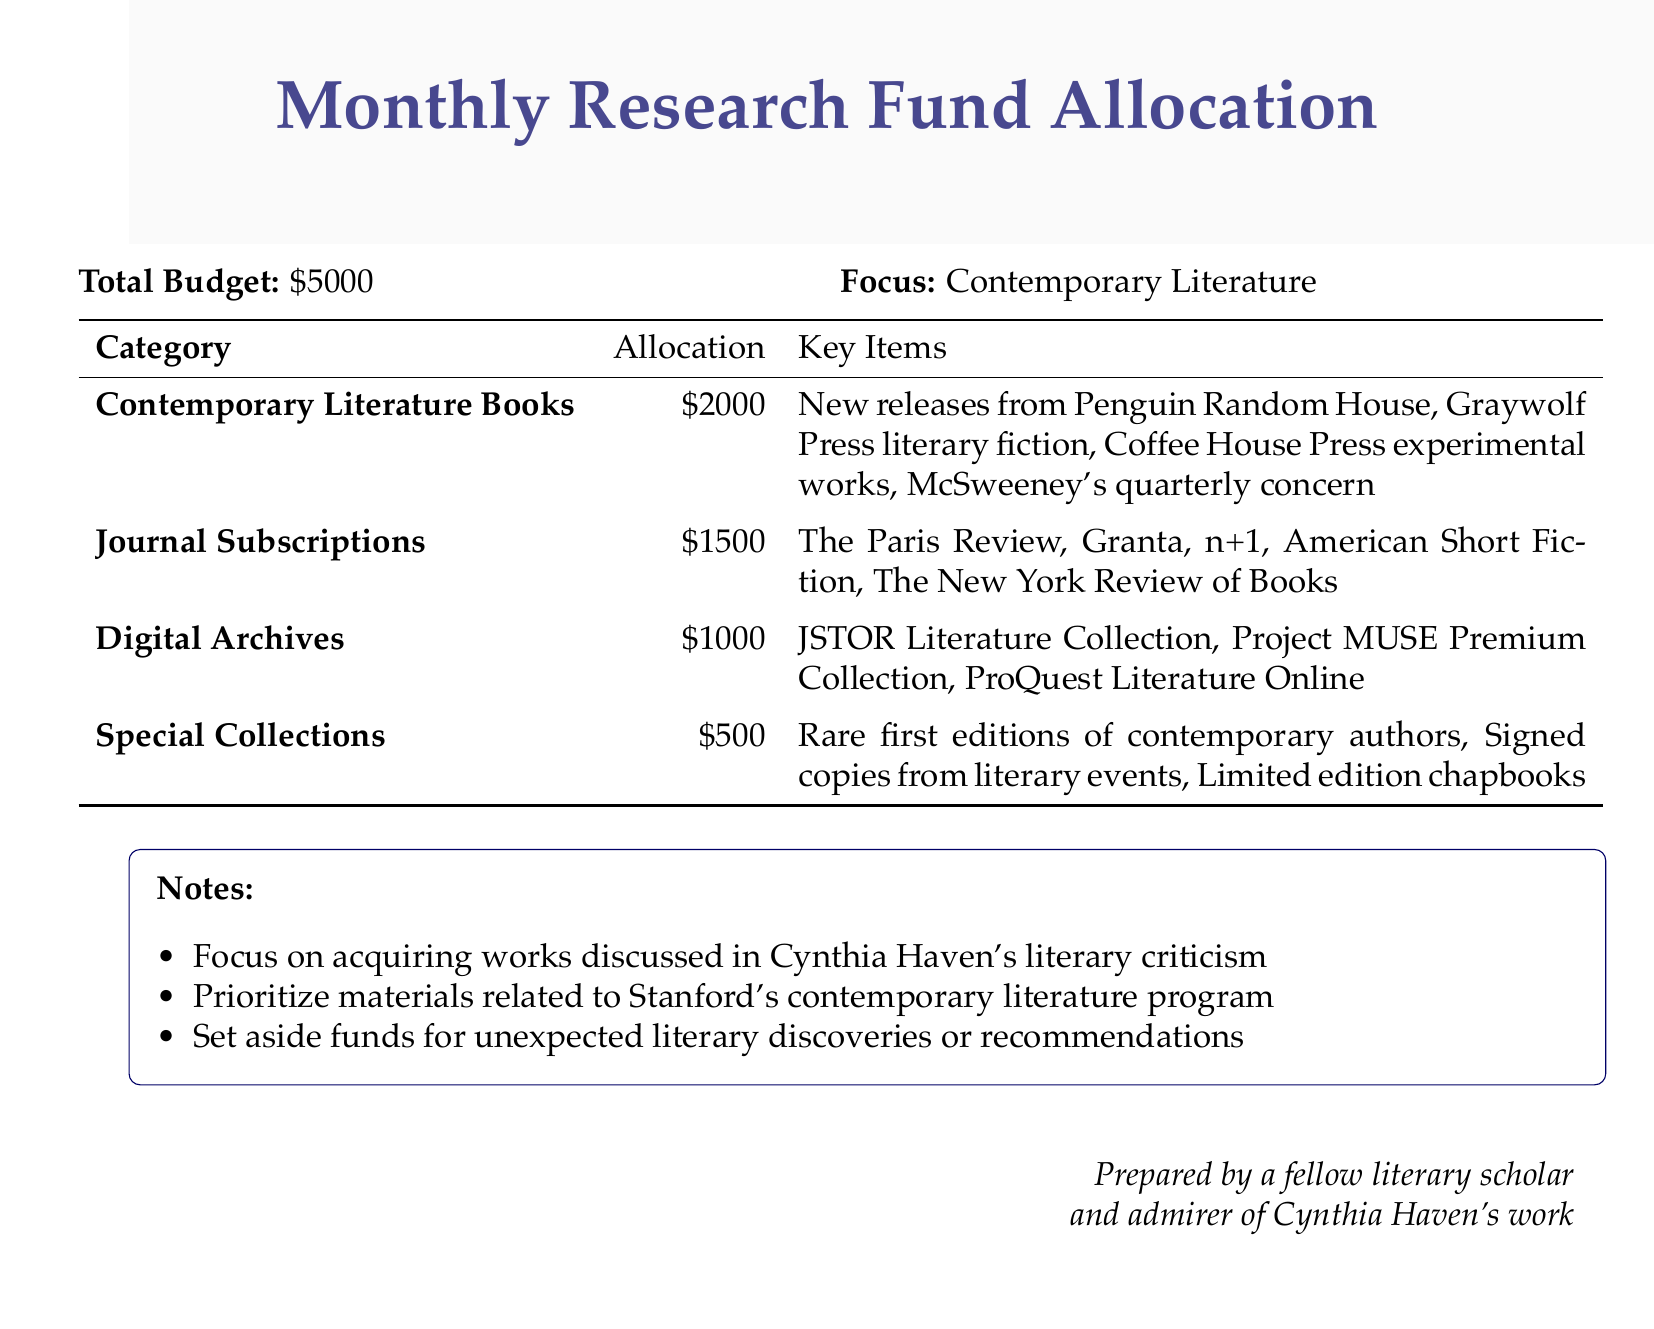What is the total budget? The total budget is clearly stated in the document as \$5000.
Answer: \$5000 How much is allocated for journal subscriptions? The document specifies that \$1500 is allocated for journal subscriptions.
Answer: \$1500 Which digital archive is included in the allocations? The document lists several digital archives, one of which is JSTOR Literature Collection.
Answer: JSTOR Literature Collection What is the allocation for special collections? The document indicates that \$500 is allocated for special collections.
Answer: \$500 What focus area is prioritized in the budget? The budget highlights a specific focus area, which is contemporary literature.
Answer: Contemporary Literature What type of books will be purchased? The document specifies that contemporary literature books will be purchased.
Answer: Contemporary Literature Books How many journal titles are specified in the allocation? The document includes five different journal titles under subscriptions.
Answer: Five What percentage of the total budget is allocated for books? The allocation for books is \$2000, which is 40% of the total budget of \$5000.
Answer: 40% What is emphasized in the notes section? The notes emphasize acquiring works discussed in Cynthia Haven's literary criticism.
Answer: Works discussed in Cynthia Haven's literary criticism 